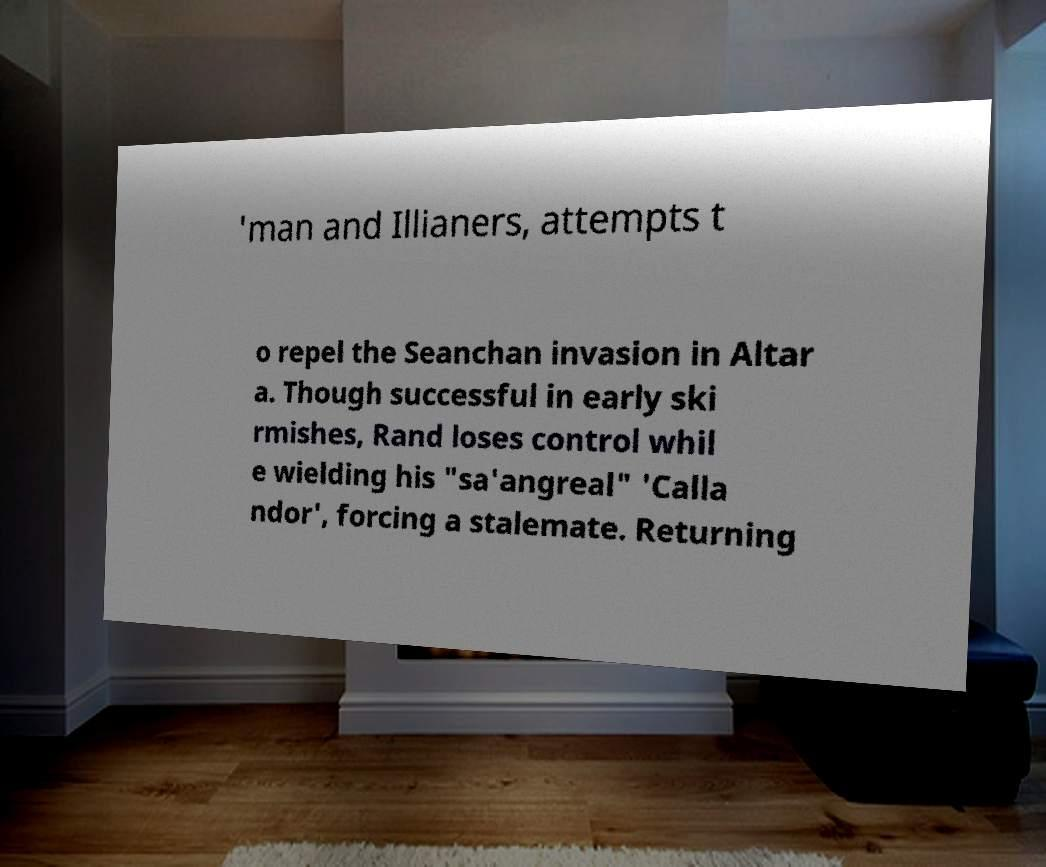What messages or text are displayed in this image? I need them in a readable, typed format. 'man and Illianers, attempts t o repel the Seanchan invasion in Altar a. Though successful in early ski rmishes, Rand loses control whil e wielding his "sa'angreal" 'Calla ndor', forcing a stalemate. Returning 